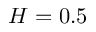<formula> <loc_0><loc_0><loc_500><loc_500>H = 0 . 5</formula> 